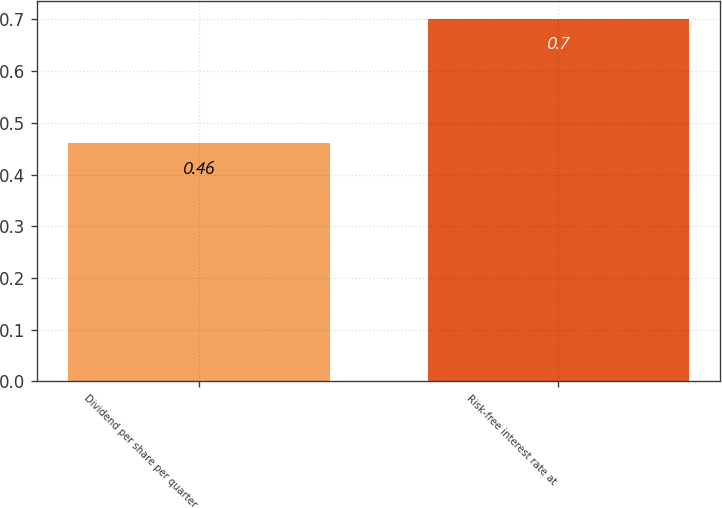Convert chart to OTSL. <chart><loc_0><loc_0><loc_500><loc_500><bar_chart><fcel>Dividend per share per quarter<fcel>Risk-free interest rate at<nl><fcel>0.46<fcel>0.7<nl></chart> 